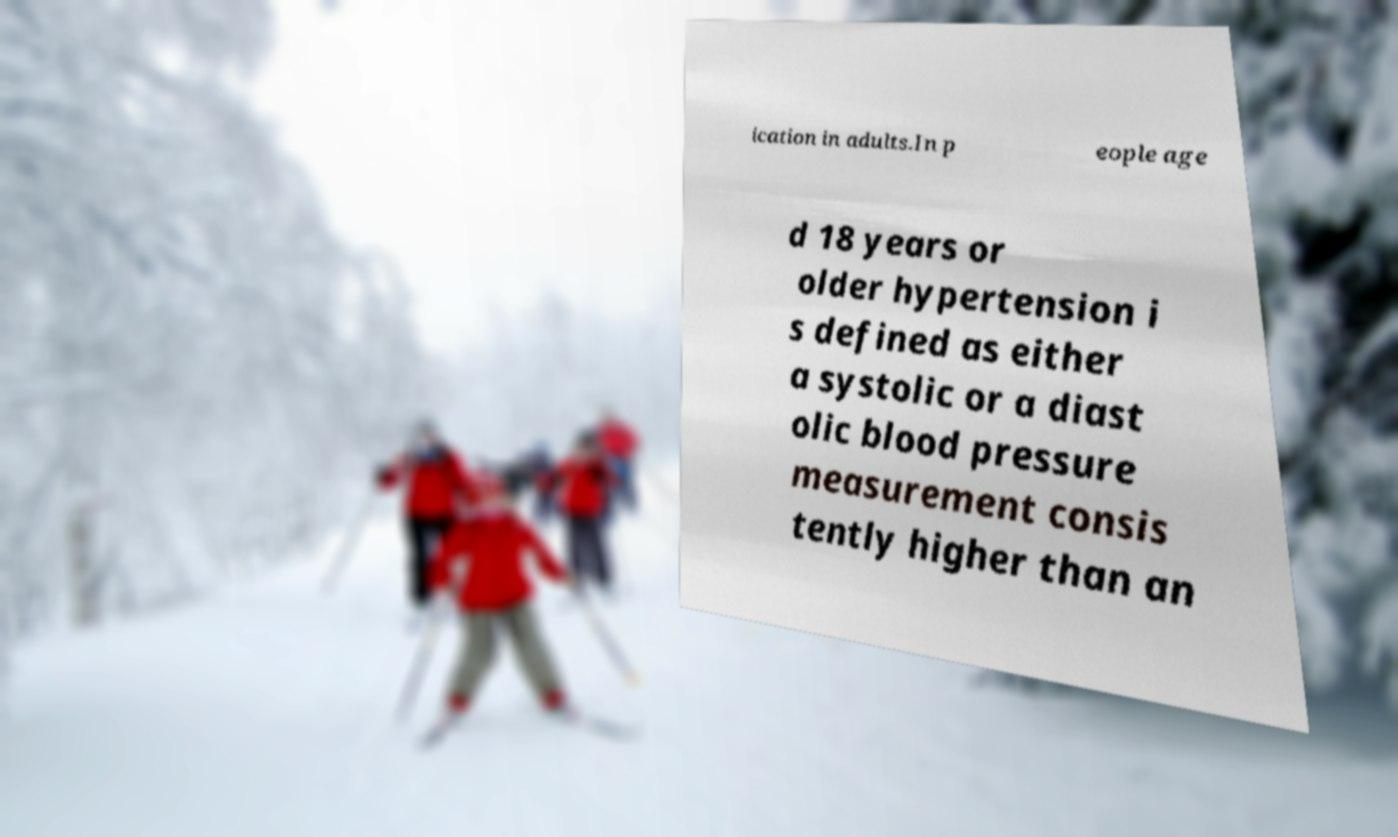Can you accurately transcribe the text from the provided image for me? ication in adults.In p eople age d 18 years or older hypertension i s defined as either a systolic or a diast olic blood pressure measurement consis tently higher than an 